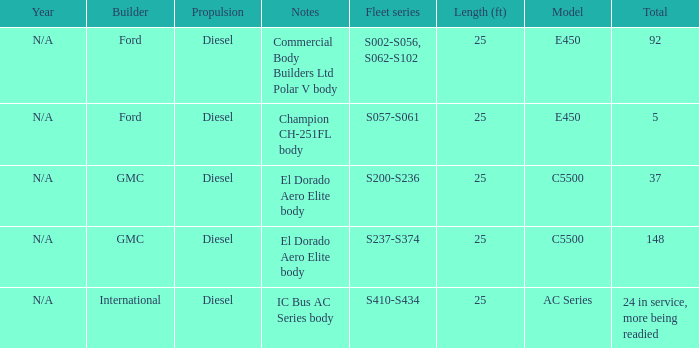Which builder has a fleet series of s057-s061? Ford. 